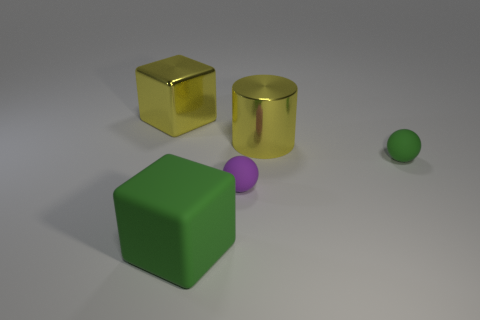What is the shape of the yellow shiny object that is the same size as the metallic cylinder?
Offer a very short reply. Cube. What number of things are either cubes or purple matte balls behind the big matte cube?
Offer a terse response. 3. Is the shiny cylinder the same color as the metallic block?
Your response must be concise. Yes. How many green objects are to the left of the tiny green ball?
Keep it short and to the point. 1. There is a big object that is the same material as the big yellow cylinder; what is its color?
Make the answer very short. Yellow. What number of shiny objects are large green objects or tiny objects?
Your response must be concise. 0. Are the purple object and the big green block made of the same material?
Your answer should be compact. Yes. There is a yellow thing that is to the right of the metal cube; what shape is it?
Ensure brevity in your answer.  Cylinder. Are there any large rubber things in front of the small green ball that is on the right side of the small purple rubber object?
Your response must be concise. Yes. Are there any purple objects of the same size as the green ball?
Provide a short and direct response. Yes. 